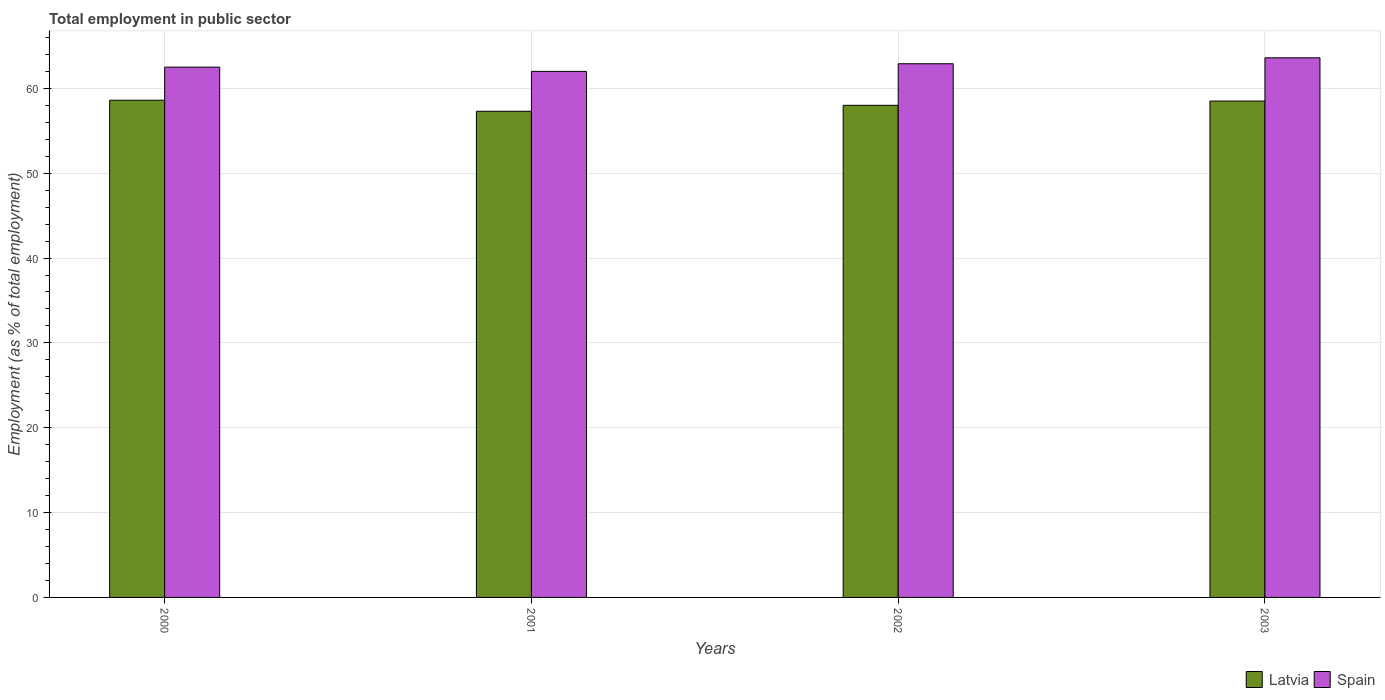How many groups of bars are there?
Make the answer very short. 4. Are the number of bars per tick equal to the number of legend labels?
Provide a short and direct response. Yes. Are the number of bars on each tick of the X-axis equal?
Your answer should be compact. Yes. How many bars are there on the 2nd tick from the left?
Your answer should be very brief. 2. What is the employment in public sector in Spain in 2000?
Keep it short and to the point. 62.5. Across all years, what is the maximum employment in public sector in Spain?
Provide a short and direct response. 63.6. In which year was the employment in public sector in Latvia minimum?
Ensure brevity in your answer.  2001. What is the total employment in public sector in Spain in the graph?
Offer a very short reply. 251. What is the difference between the employment in public sector in Latvia in 2000 and that in 2003?
Your answer should be very brief. 0.1. What is the average employment in public sector in Spain per year?
Provide a short and direct response. 62.75. In the year 2003, what is the difference between the employment in public sector in Spain and employment in public sector in Latvia?
Offer a very short reply. 5.1. In how many years, is the employment in public sector in Latvia greater than 40 %?
Provide a short and direct response. 4. What is the ratio of the employment in public sector in Spain in 2002 to that in 2003?
Offer a terse response. 0.99. Is the employment in public sector in Spain in 2001 less than that in 2002?
Your response must be concise. Yes. Is the difference between the employment in public sector in Spain in 2002 and 2003 greater than the difference between the employment in public sector in Latvia in 2002 and 2003?
Provide a short and direct response. No. What is the difference between the highest and the second highest employment in public sector in Spain?
Your response must be concise. 0.7. What is the difference between the highest and the lowest employment in public sector in Spain?
Give a very brief answer. 1.6. In how many years, is the employment in public sector in Spain greater than the average employment in public sector in Spain taken over all years?
Ensure brevity in your answer.  2. Is the sum of the employment in public sector in Spain in 2000 and 2001 greater than the maximum employment in public sector in Latvia across all years?
Ensure brevity in your answer.  Yes. What does the 1st bar from the left in 2003 represents?
Make the answer very short. Latvia. What does the 2nd bar from the right in 2002 represents?
Provide a short and direct response. Latvia. How many bars are there?
Your answer should be compact. 8. What is the difference between two consecutive major ticks on the Y-axis?
Make the answer very short. 10. Does the graph contain any zero values?
Offer a terse response. No. Does the graph contain grids?
Offer a very short reply. Yes. How many legend labels are there?
Your answer should be compact. 2. What is the title of the graph?
Offer a terse response. Total employment in public sector. What is the label or title of the X-axis?
Your response must be concise. Years. What is the label or title of the Y-axis?
Your answer should be very brief. Employment (as % of total employment). What is the Employment (as % of total employment) in Latvia in 2000?
Ensure brevity in your answer.  58.6. What is the Employment (as % of total employment) in Spain in 2000?
Your answer should be very brief. 62.5. What is the Employment (as % of total employment) in Latvia in 2001?
Offer a very short reply. 57.3. What is the Employment (as % of total employment) of Latvia in 2002?
Your answer should be very brief. 58. What is the Employment (as % of total employment) of Spain in 2002?
Your response must be concise. 62.9. What is the Employment (as % of total employment) of Latvia in 2003?
Provide a succinct answer. 58.5. What is the Employment (as % of total employment) of Spain in 2003?
Keep it short and to the point. 63.6. Across all years, what is the maximum Employment (as % of total employment) in Latvia?
Keep it short and to the point. 58.6. Across all years, what is the maximum Employment (as % of total employment) of Spain?
Make the answer very short. 63.6. Across all years, what is the minimum Employment (as % of total employment) of Latvia?
Give a very brief answer. 57.3. Across all years, what is the minimum Employment (as % of total employment) of Spain?
Offer a very short reply. 62. What is the total Employment (as % of total employment) in Latvia in the graph?
Your answer should be compact. 232.4. What is the total Employment (as % of total employment) in Spain in the graph?
Give a very brief answer. 251. What is the difference between the Employment (as % of total employment) in Latvia in 2000 and that in 2002?
Offer a very short reply. 0.6. What is the difference between the Employment (as % of total employment) in Spain in 2000 and that in 2002?
Make the answer very short. -0.4. What is the difference between the Employment (as % of total employment) of Spain in 2001 and that in 2002?
Your response must be concise. -0.9. What is the difference between the Employment (as % of total employment) of Latvia in 2002 and that in 2003?
Your answer should be very brief. -0.5. What is the difference between the Employment (as % of total employment) in Spain in 2002 and that in 2003?
Ensure brevity in your answer.  -0.7. What is the difference between the Employment (as % of total employment) in Latvia in 2000 and the Employment (as % of total employment) in Spain in 2002?
Give a very brief answer. -4.3. What is the difference between the Employment (as % of total employment) in Latvia in 2001 and the Employment (as % of total employment) in Spain in 2002?
Your answer should be very brief. -5.6. What is the difference between the Employment (as % of total employment) in Latvia in 2001 and the Employment (as % of total employment) in Spain in 2003?
Your response must be concise. -6.3. What is the average Employment (as % of total employment) of Latvia per year?
Ensure brevity in your answer.  58.1. What is the average Employment (as % of total employment) of Spain per year?
Give a very brief answer. 62.75. In the year 2000, what is the difference between the Employment (as % of total employment) of Latvia and Employment (as % of total employment) of Spain?
Your answer should be compact. -3.9. In the year 2001, what is the difference between the Employment (as % of total employment) of Latvia and Employment (as % of total employment) of Spain?
Ensure brevity in your answer.  -4.7. In the year 2003, what is the difference between the Employment (as % of total employment) of Latvia and Employment (as % of total employment) of Spain?
Provide a short and direct response. -5.1. What is the ratio of the Employment (as % of total employment) of Latvia in 2000 to that in 2001?
Your response must be concise. 1.02. What is the ratio of the Employment (as % of total employment) in Spain in 2000 to that in 2001?
Offer a terse response. 1.01. What is the ratio of the Employment (as % of total employment) in Latvia in 2000 to that in 2002?
Offer a very short reply. 1.01. What is the ratio of the Employment (as % of total employment) in Spain in 2000 to that in 2003?
Your answer should be very brief. 0.98. What is the ratio of the Employment (as % of total employment) of Latvia in 2001 to that in 2002?
Give a very brief answer. 0.99. What is the ratio of the Employment (as % of total employment) of Spain in 2001 to that in 2002?
Provide a succinct answer. 0.99. What is the ratio of the Employment (as % of total employment) in Latvia in 2001 to that in 2003?
Give a very brief answer. 0.98. What is the ratio of the Employment (as % of total employment) of Spain in 2001 to that in 2003?
Make the answer very short. 0.97. What is the ratio of the Employment (as % of total employment) of Latvia in 2002 to that in 2003?
Provide a short and direct response. 0.99. What is the difference between the highest and the second highest Employment (as % of total employment) of Latvia?
Provide a short and direct response. 0.1. What is the difference between the highest and the second highest Employment (as % of total employment) of Spain?
Make the answer very short. 0.7. What is the difference between the highest and the lowest Employment (as % of total employment) in Spain?
Ensure brevity in your answer.  1.6. 